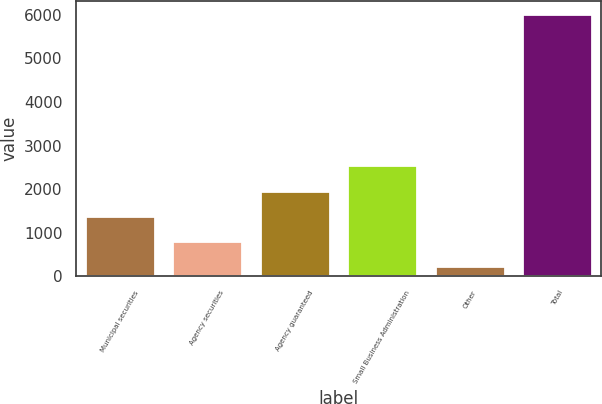Convert chart. <chart><loc_0><loc_0><loc_500><loc_500><bar_chart><fcel>Municipal securities<fcel>Agency securities<fcel>Agency guaranteed<fcel>Small Business Administration<fcel>Other<fcel>Total<nl><fcel>1385<fcel>805.5<fcel>1964.5<fcel>2544<fcel>226<fcel>6021<nl></chart> 